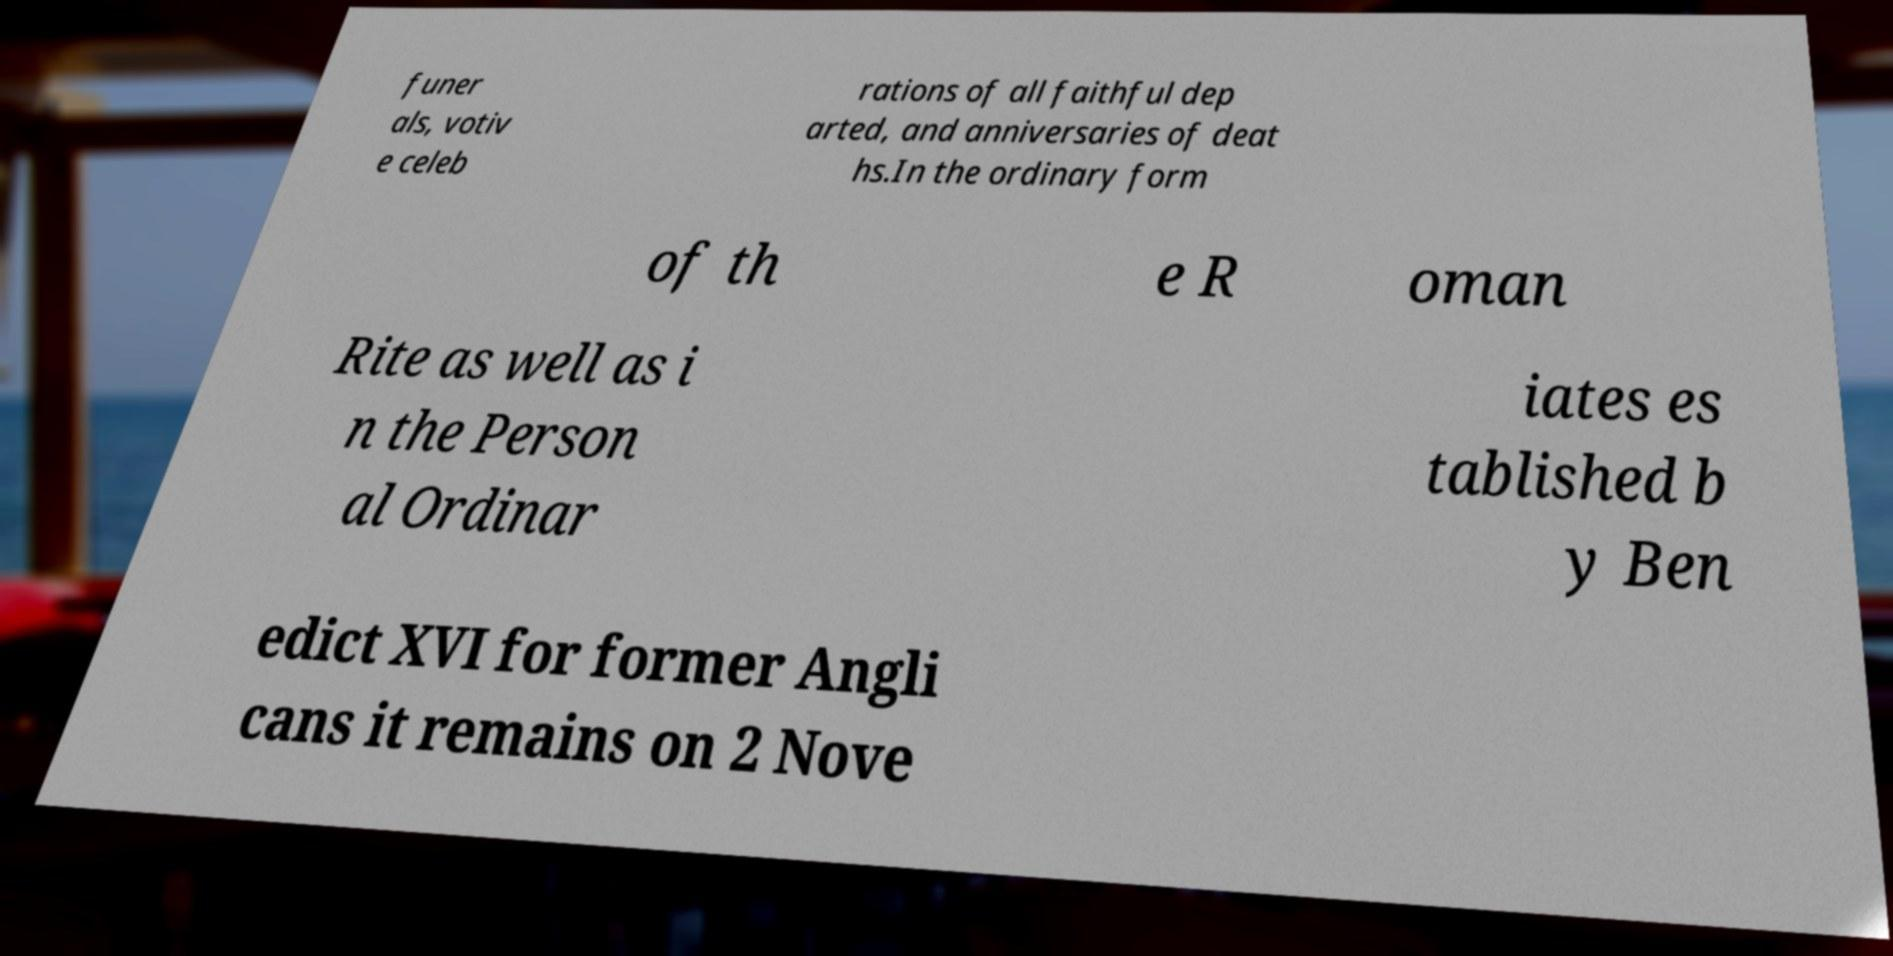Could you extract and type out the text from this image? funer als, votiv e celeb rations of all faithful dep arted, and anniversaries of deat hs.In the ordinary form of th e R oman Rite as well as i n the Person al Ordinar iates es tablished b y Ben edict XVI for former Angli cans it remains on 2 Nove 